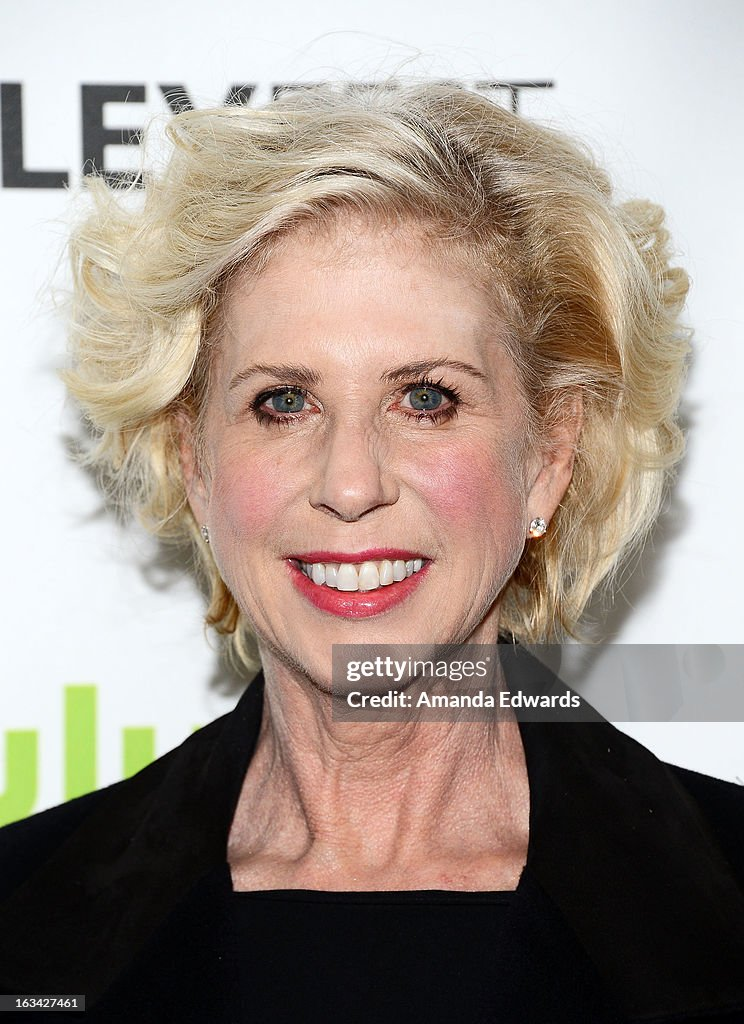Imagine the stories or events that might unfold at this event. What do you think is happening behind the scenes? Behind the scenes, the event is a whirlwind of preparations and activity. Publicists are coordinating schedules, photographers are setting up their equipment, and celebrities are getting ready – touching up makeup, adjusting attire, and preparing soundbites for the press. There's a constant buzz of organizing interviews, ensuring everyone is where they need to be, and managing logistics to keep everything running smoothly. The air is filled with a mix of professionalism and excitement, as everyone works together to create a seamless and memorable event. Can you speculate on some specific conversations or interactions taking place among attendees? Attendees might be engaging in a range of conversations, from career discussions to casual chit-chat. For instance, a director might be discussing upcoming projects with a leading actor, while another group might be reminiscing about their experiences on set. Publicists might be coordinating interviews with media outlets, while fashion enthusiasts comment on each other’s attire. There’s a blend of professional networking, friendly banter, and the occasional praise-worthy compliment exchanging hands, contributing to a vibrant and interconnected atmosphere. What are some unexpected twists or surprises that could occur during such an event? Unexpected twists at such events can be quite thrilling. An unannounced appearance by a mega-celebrity can send waves of excitement through the crowd. A surprise performance or an impromptu speech can also elevate the event significantly. Technical glitches, such as a microphone malfunction during a live interview, can create memorable moments as attendees navigate the hiccup with humor and grace. Sometimes, unscheduled interactions between celebrities can lead to intriguing and newsworthy encounters, adding an element of spontaneity to the formal setting. 